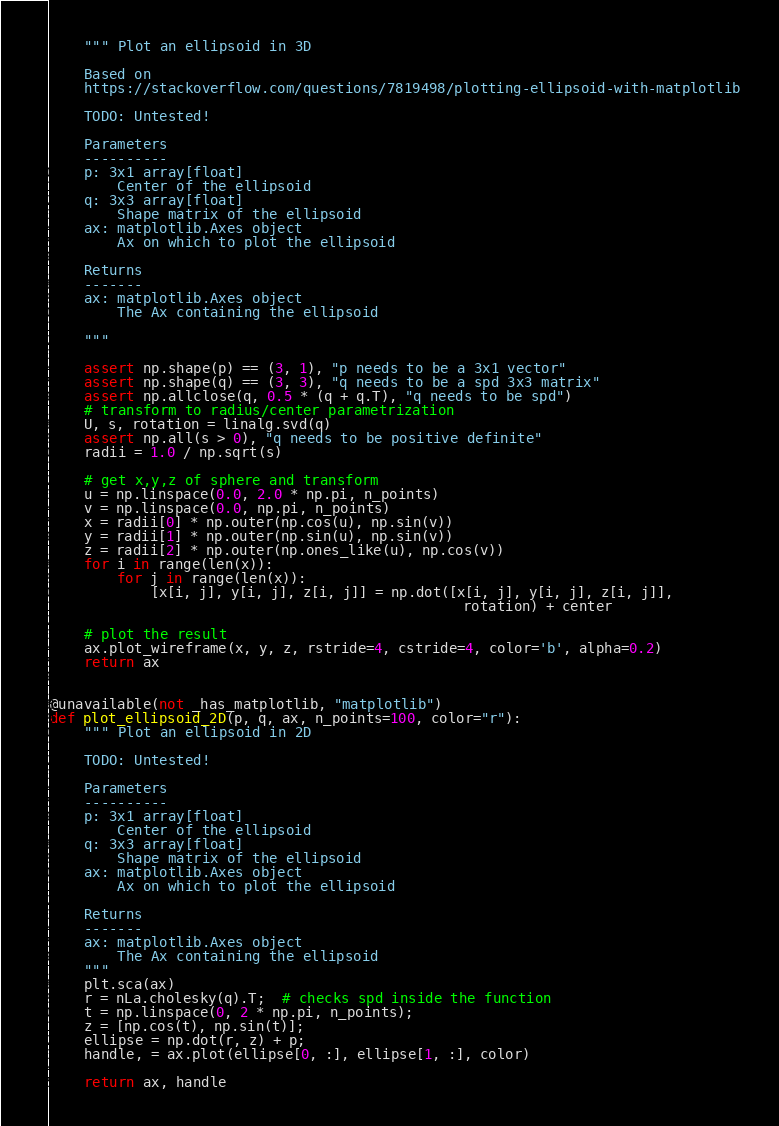<code> <loc_0><loc_0><loc_500><loc_500><_Python_>    """ Plot an ellipsoid in 3D

    Based on
    https://stackoverflow.com/questions/7819498/plotting-ellipsoid-with-matplotlib

    TODO: Untested!

    Parameters
    ----------
    p: 3x1 array[float]
        Center of the ellipsoid
    q: 3x3 array[float]
        Shape matrix of the ellipsoid
    ax: matplotlib.Axes object
        Ax on which to plot the ellipsoid

    Returns
    -------
    ax: matplotlib.Axes object
        The Ax containing the ellipsoid

    """

    assert np.shape(p) == (3, 1), "p needs to be a 3x1 vector"
    assert np.shape(q) == (3, 3), "q needs to be a spd 3x3 matrix"
    assert np.allclose(q, 0.5 * (q + q.T), "q needs to be spd")
    # transform to radius/center parametrization
    U, s, rotation = linalg.svd(q)
    assert np.all(s > 0), "q needs to be positive definite"
    radii = 1.0 / np.sqrt(s)

    # get x,y,z of sphere and transform
    u = np.linspace(0.0, 2.0 * np.pi, n_points)
    v = np.linspace(0.0, np.pi, n_points)
    x = radii[0] * np.outer(np.cos(u), np.sin(v))
    y = radii[1] * np.outer(np.sin(u), np.sin(v))
    z = radii[2] * np.outer(np.ones_like(u), np.cos(v))
    for i in range(len(x)):
        for j in range(len(x)):
            [x[i, j], y[i, j], z[i, j]] = np.dot([x[i, j], y[i, j], z[i, j]],
                                                 rotation) + center

    # plot the result
    ax.plot_wireframe(x, y, z, rstride=4, cstride=4, color='b', alpha=0.2)
    return ax


@unavailable(not _has_matplotlib, "matplotlib")
def plot_ellipsoid_2D(p, q, ax, n_points=100, color="r"):
    """ Plot an ellipsoid in 2D

    TODO: Untested!

    Parameters
    ----------
    p: 3x1 array[float]
        Center of the ellipsoid
    q: 3x3 array[float]
        Shape matrix of the ellipsoid
    ax: matplotlib.Axes object
        Ax on which to plot the ellipsoid

    Returns
    -------
    ax: matplotlib.Axes object
        The Ax containing the ellipsoid
    """
    plt.sca(ax)
    r = nLa.cholesky(q).T;  # checks spd inside the function
    t = np.linspace(0, 2 * np.pi, n_points);
    z = [np.cos(t), np.sin(t)];
    ellipse = np.dot(r, z) + p;
    handle, = ax.plot(ellipse[0, :], ellipse[1, :], color)

    return ax, handle
</code> 